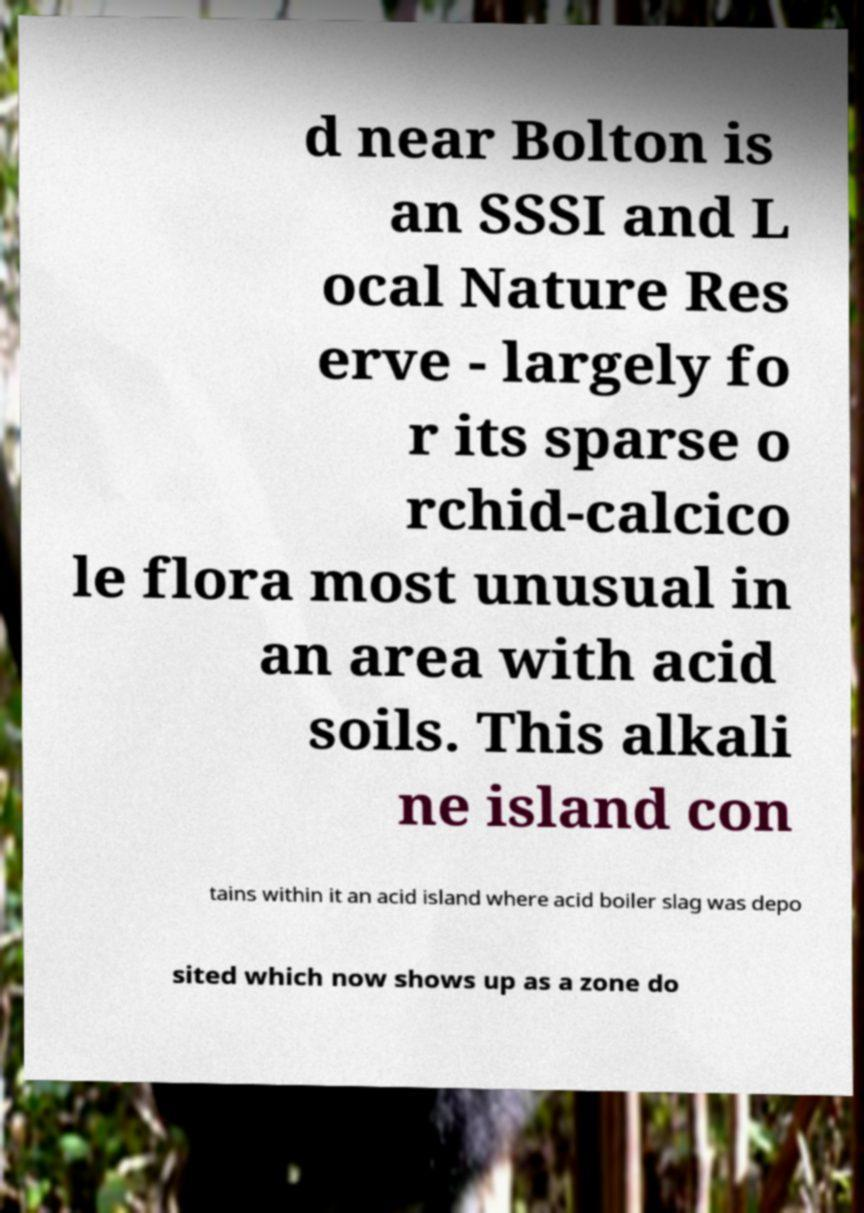Could you extract and type out the text from this image? d near Bolton is an SSSI and L ocal Nature Res erve - largely fo r its sparse o rchid-calcico le flora most unusual in an area with acid soils. This alkali ne island con tains within it an acid island where acid boiler slag was depo sited which now shows up as a zone do 